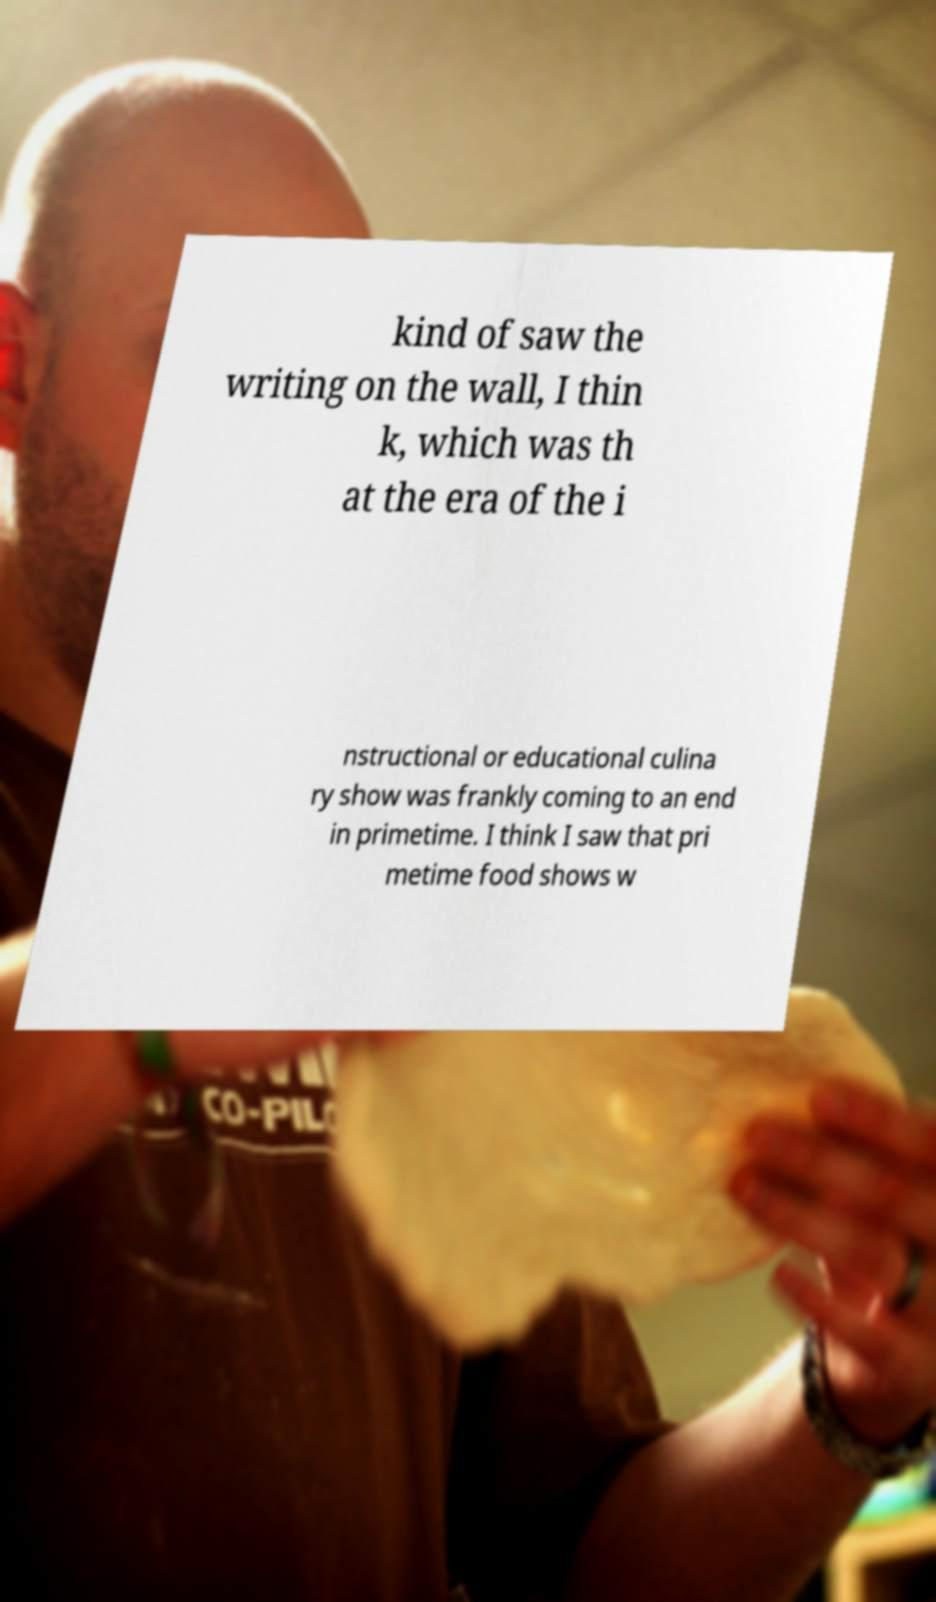There's text embedded in this image that I need extracted. Can you transcribe it verbatim? kind of saw the writing on the wall, I thin k, which was th at the era of the i nstructional or educational culina ry show was frankly coming to an end in primetime. I think I saw that pri metime food shows w 